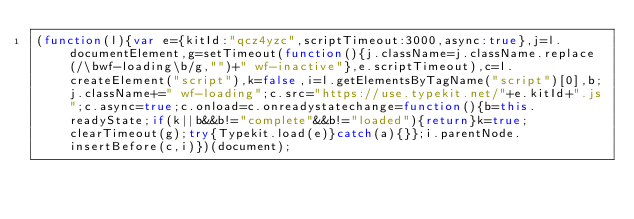Convert code to text. <code><loc_0><loc_0><loc_500><loc_500><_JavaScript_>(function(l){var e={kitId:"qcz4yzc",scriptTimeout:3000,async:true},j=l.documentElement,g=setTimeout(function(){j.className=j.className.replace(/\bwf-loading\b/g,"")+" wf-inactive"},e.scriptTimeout),c=l.createElement("script"),k=false,i=l.getElementsByTagName("script")[0],b;j.className+=" wf-loading";c.src="https://use.typekit.net/"+e.kitId+".js";c.async=true;c.onload=c.onreadystatechange=function(){b=this.readyState;if(k||b&&b!="complete"&&b!="loaded"){return}k=true;clearTimeout(g);try{Typekit.load(e)}catch(a){}};i.parentNode.insertBefore(c,i)})(document);</code> 